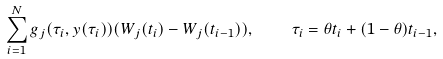Convert formula to latex. <formula><loc_0><loc_0><loc_500><loc_500>\sum _ { i = 1 } ^ { N } g _ { j } ( \tau _ { i } , y ( \tau _ { i } ) ) ( W _ { j } ( t _ { i } ) - W _ { j } ( t _ { i - 1 } ) ) , \quad \tau _ { i } = \theta t _ { i } + ( 1 - \theta ) t _ { i - 1 } ,</formula> 